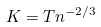<formula> <loc_0><loc_0><loc_500><loc_500>K = T n ^ { - 2 / 3 }</formula> 